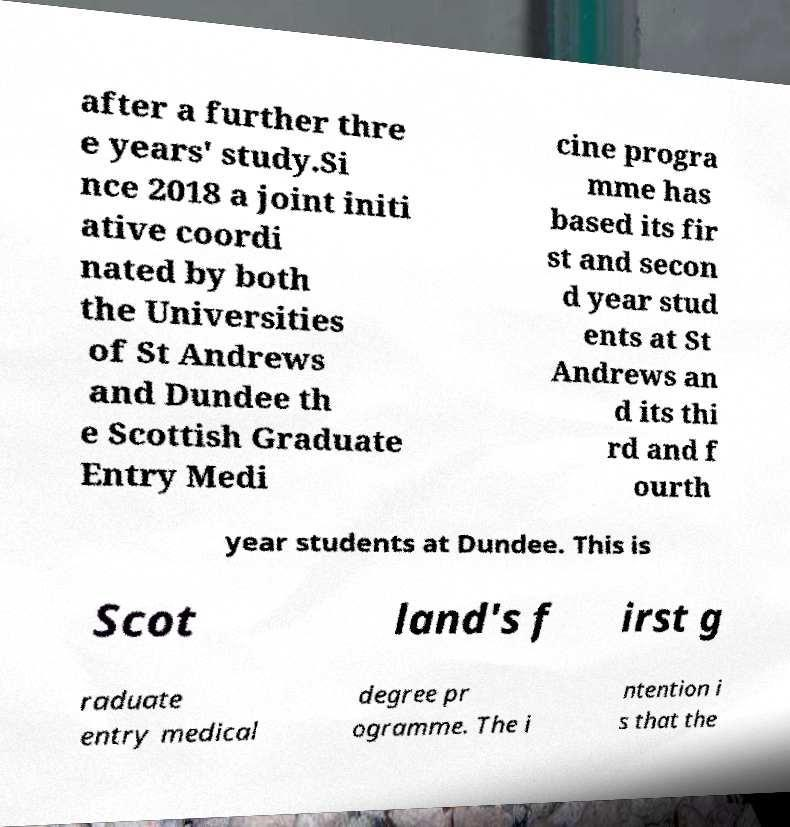Can you read and provide the text displayed in the image?This photo seems to have some interesting text. Can you extract and type it out for me? after a further thre e years' study.Si nce 2018 a joint initi ative coordi nated by both the Universities of St Andrews and Dundee th e Scottish Graduate Entry Medi cine progra mme has based its fir st and secon d year stud ents at St Andrews an d its thi rd and f ourth year students at Dundee. This is Scot land's f irst g raduate entry medical degree pr ogramme. The i ntention i s that the 